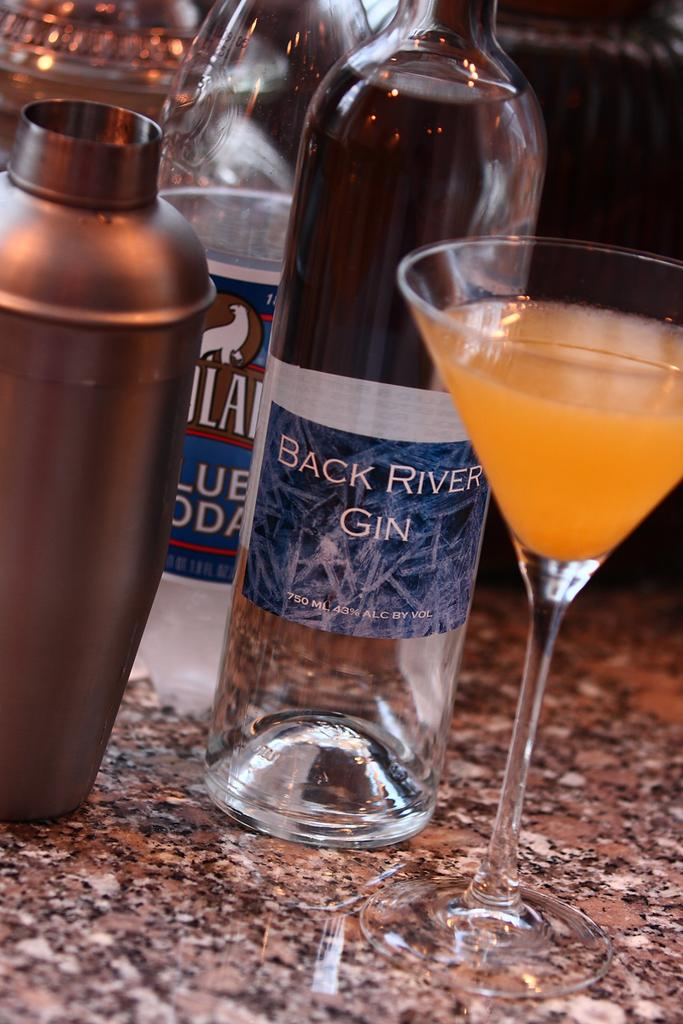<image>
Offer a succinct explanation of the picture presented. A bottle of Black River Gin sits next to an orange drink. 